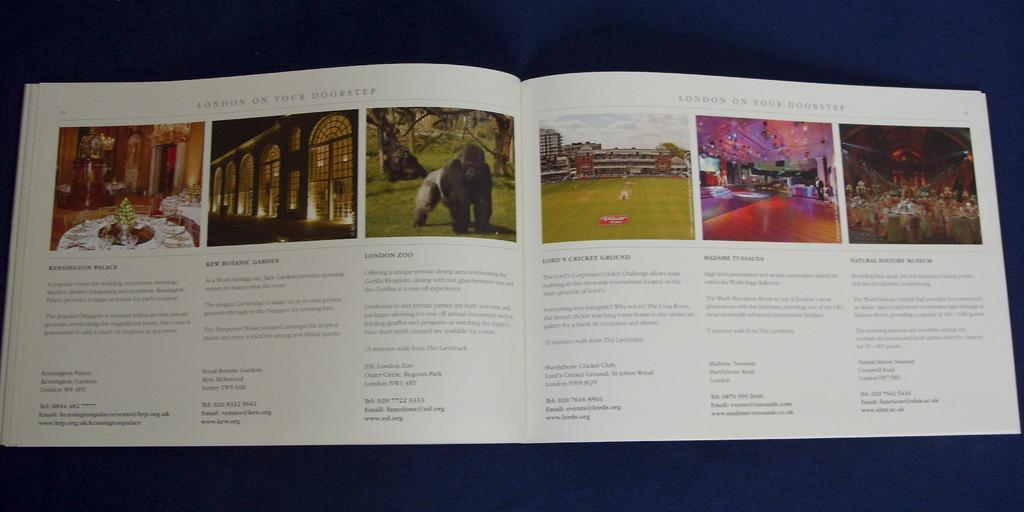<image>
Write a terse but informative summary of the picture. A book is open and the heading for the page is London on Your Doorstep. 